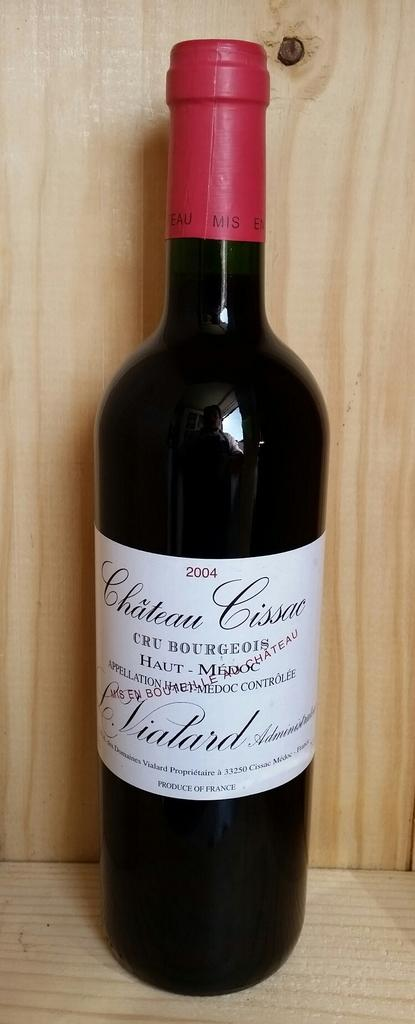<image>
Create a compact narrative representing the image presented. A bottle of Chateau Cissac was bottled in the year 2004. 